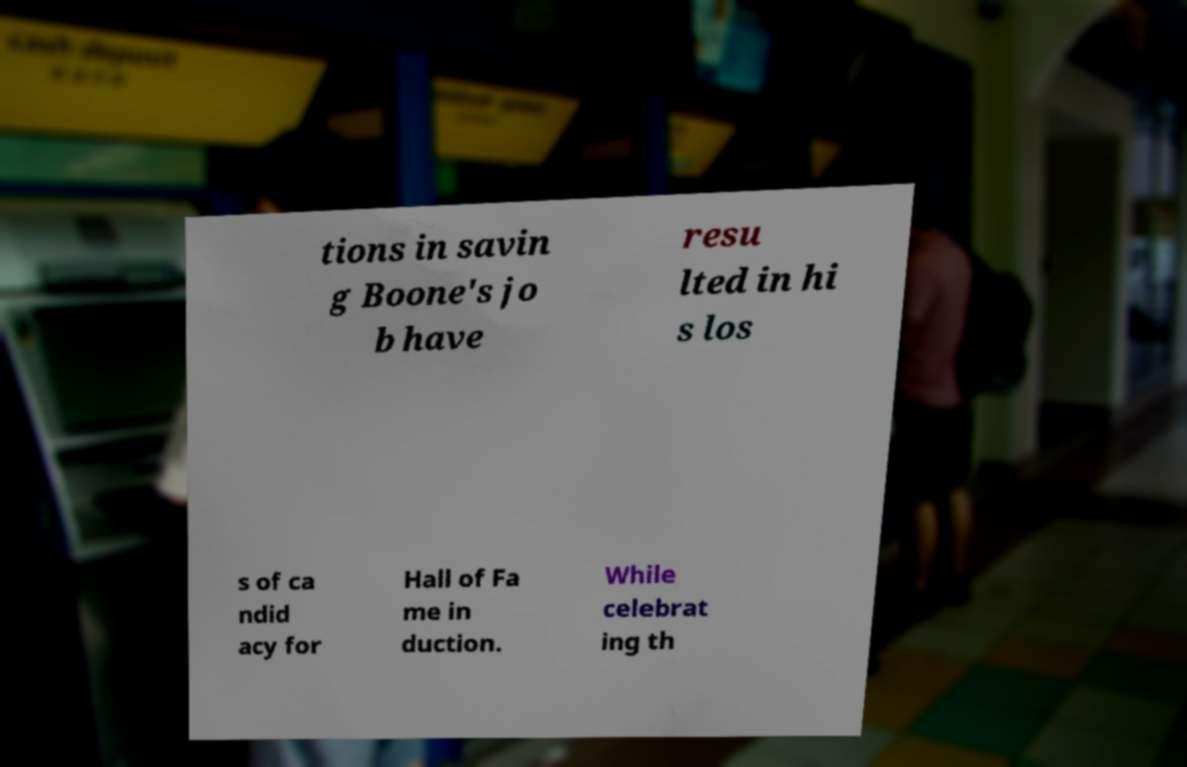What messages or text are displayed in this image? I need them in a readable, typed format. tions in savin g Boone's jo b have resu lted in hi s los s of ca ndid acy for Hall of Fa me in duction. While celebrat ing th 